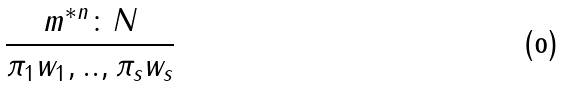Convert formula to latex. <formula><loc_0><loc_0><loc_500><loc_500>\frac { m ^ { * n } \colon N } { { \pi } _ { 1 } w _ { 1 } , . . , { \pi } _ { s } w _ { s } }</formula> 